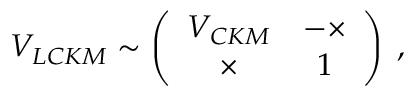Convert formula to latex. <formula><loc_0><loc_0><loc_500><loc_500>V _ { L C K M } \sim \left ( \begin{array} { c c } { { V _ { C K M } } } & { - \times } \\ { \times } & { 1 } \end{array} \right ) \, ,</formula> 